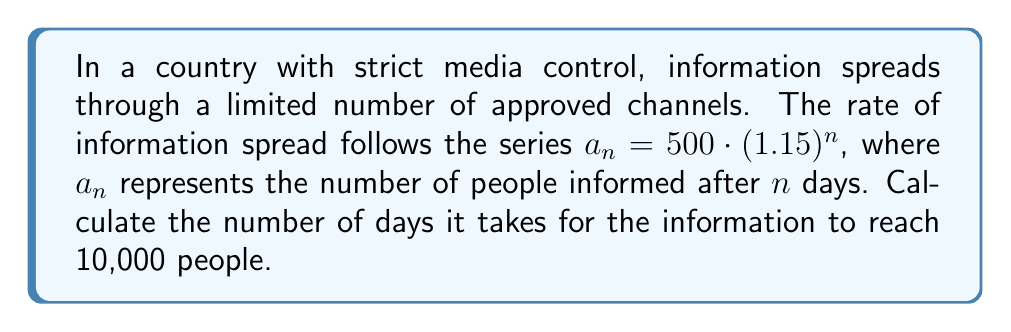Provide a solution to this math problem. To solve this problem, we need to use the given series formula and solve for $n$ when $a_n = 10,000$.

1) We start with the equation:
   $a_n = 500 \cdot (1.15)^n = 10,000$

2) Divide both sides by 500:
   $(1.15)^n = 20$

3) Take the natural logarithm of both sides:
   $n \cdot \ln(1.15) = \ln(20)$

4) Solve for $n$:
   $n = \frac{\ln(20)}{\ln(1.15)}$

5) Calculate the value:
   $n = \frac{\ln(20)}{\ln(1.15)} \approx 20.0158$

6) Since we can't have a fractional number of days, we round up to the next whole number.

Therefore, it takes 21 days for the information to reach 10,000 people in this controlled media environment.
Answer: 21 days 